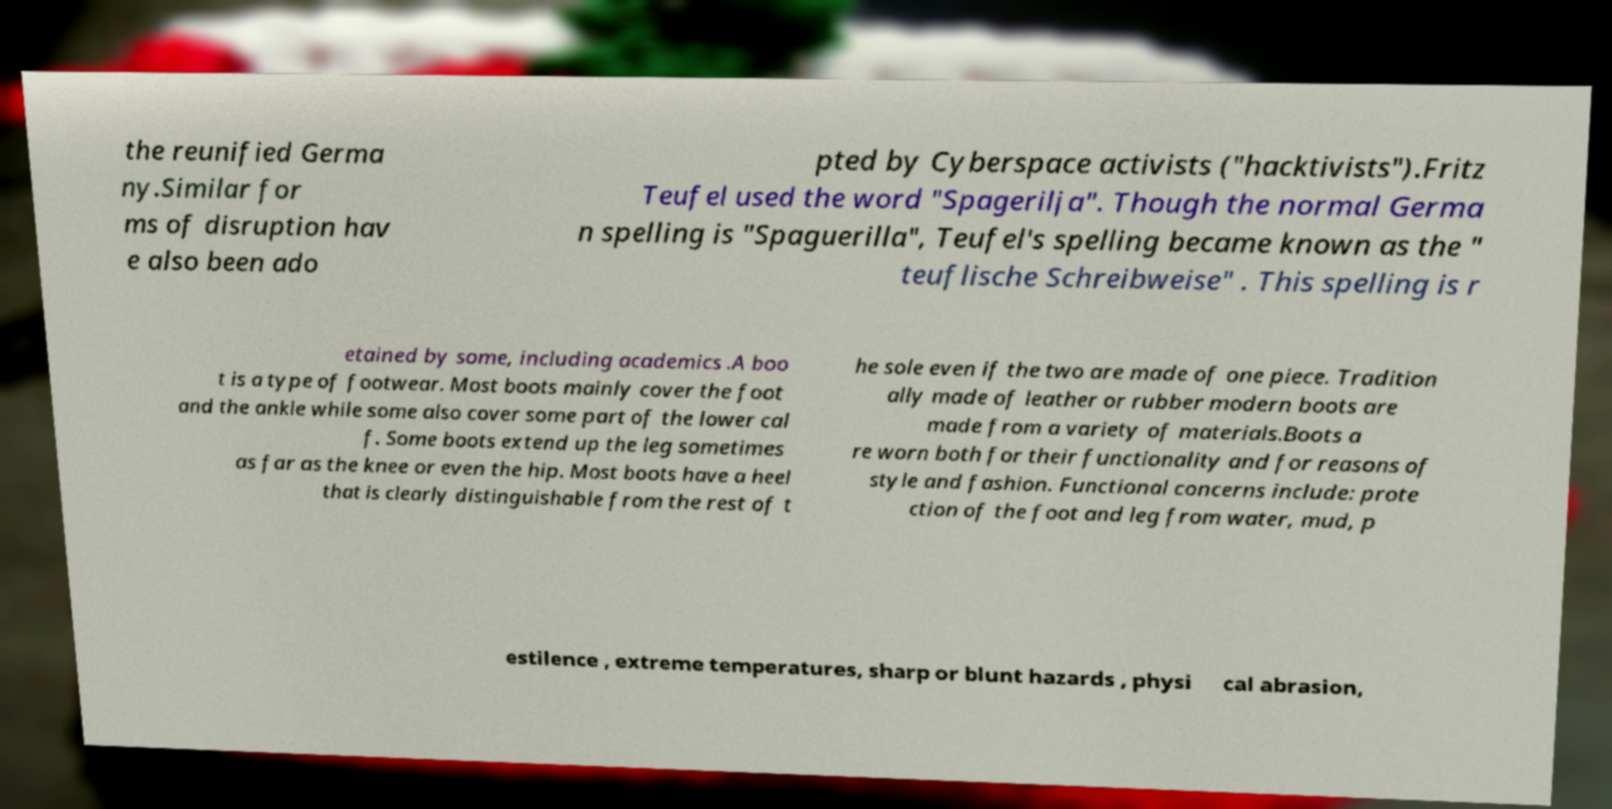There's text embedded in this image that I need extracted. Can you transcribe it verbatim? the reunified Germa ny.Similar for ms of disruption hav e also been ado pted by Cyberspace activists ("hacktivists").Fritz Teufel used the word "Spagerilja". Though the normal Germa n spelling is "Spaguerilla", Teufel's spelling became known as the " teuflische Schreibweise" . This spelling is r etained by some, including academics .A boo t is a type of footwear. Most boots mainly cover the foot and the ankle while some also cover some part of the lower cal f. Some boots extend up the leg sometimes as far as the knee or even the hip. Most boots have a heel that is clearly distinguishable from the rest of t he sole even if the two are made of one piece. Tradition ally made of leather or rubber modern boots are made from a variety of materials.Boots a re worn both for their functionality and for reasons of style and fashion. Functional concerns include: prote ction of the foot and leg from water, mud, p estilence , extreme temperatures, sharp or blunt hazards , physi cal abrasion, 